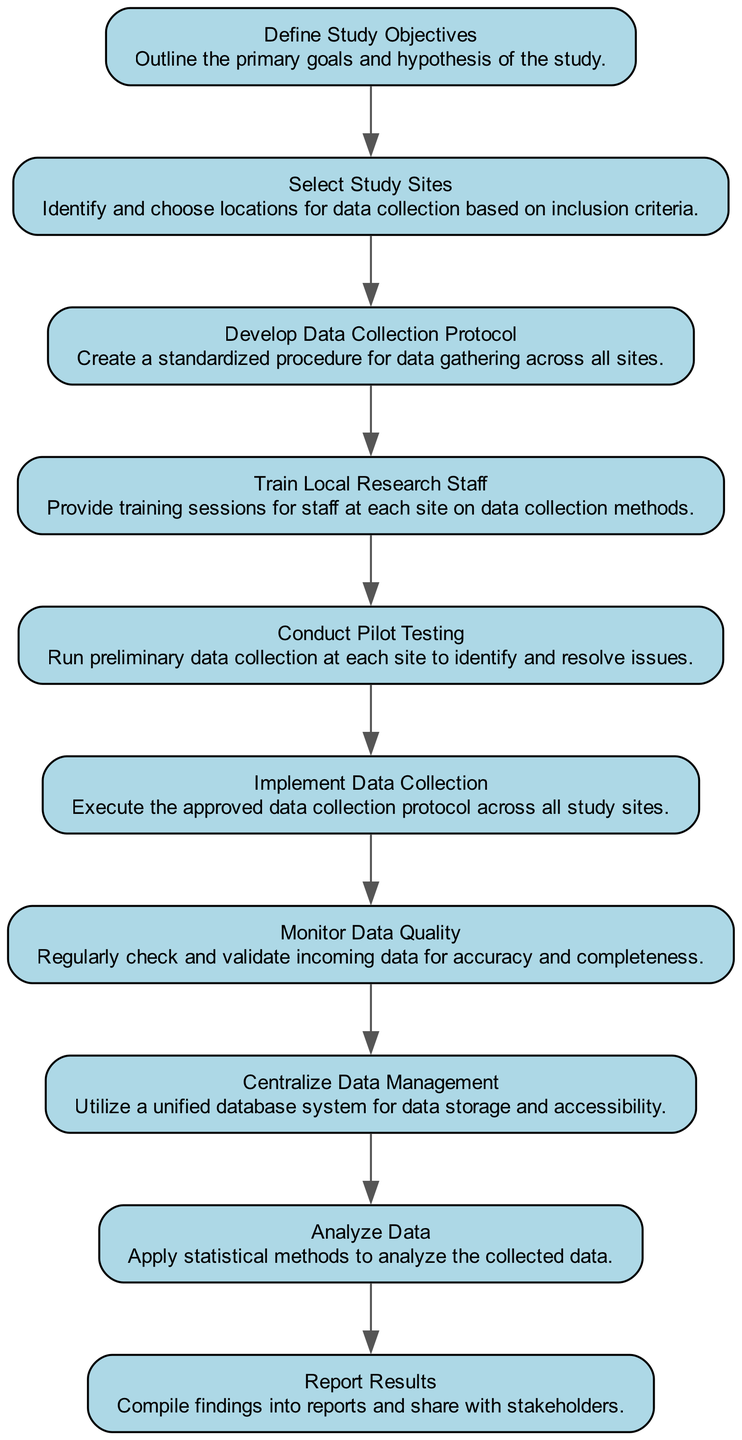What is the first step in the workflow? The first element in the flow chart is "Define Study Objectives," indicating that this is the starting point of the workflow.
Answer: Define Study Objectives How many steps are there in total? The diagram contains a total of ten distinct elements (or steps) from start to finish, as listed in the data.
Answer: 10 What follows "Select Study Sites"? "Develop Data Collection Protocol" is the subsequent step that follows after "Select Study Sites" in the flow of the diagram.
Answer: Develop Data Collection Protocol Is "Analyze Data" the last step? Yes, "Analyze Data" is the second to last step, and the final step is "Report Results," making it actually not the last step but the second to last.
Answer: No What is done after "Train Local Research Staff"? The next step after "Train Local Research Staff" is "Conduct Pilot Testing," indicating it's a progression in the workflow.
Answer: Conduct Pilot Testing What step involves data storage? "Centralize Data Management" is the step that focuses on utilizing a unified database system for data storage and accessibility in the workflow.
Answer: Centralize Data Management Which step focuses on quality assurance? "Monitor Data Quality" specifically targets the aspect of ensuring the accuracy and completeness of the incoming data throughout the project.
Answer: Monitor Data Quality How are the study sites chosen? Study sites are chosen based on specific criteria outlined in the "Select Study Sites" step.
Answer: Inclusion criteria What is the purpose of "Conduct Pilot Testing"? The purpose of this step is to run preliminary data collection at each site to identify and resolve any potential issues before full implementation.
Answer: Identify and resolve issues What is the final action taken in the workflow? The last action in the workflow is "Report Results," where findings are compiled into reports and shared with stakeholders.
Answer: Report Results 